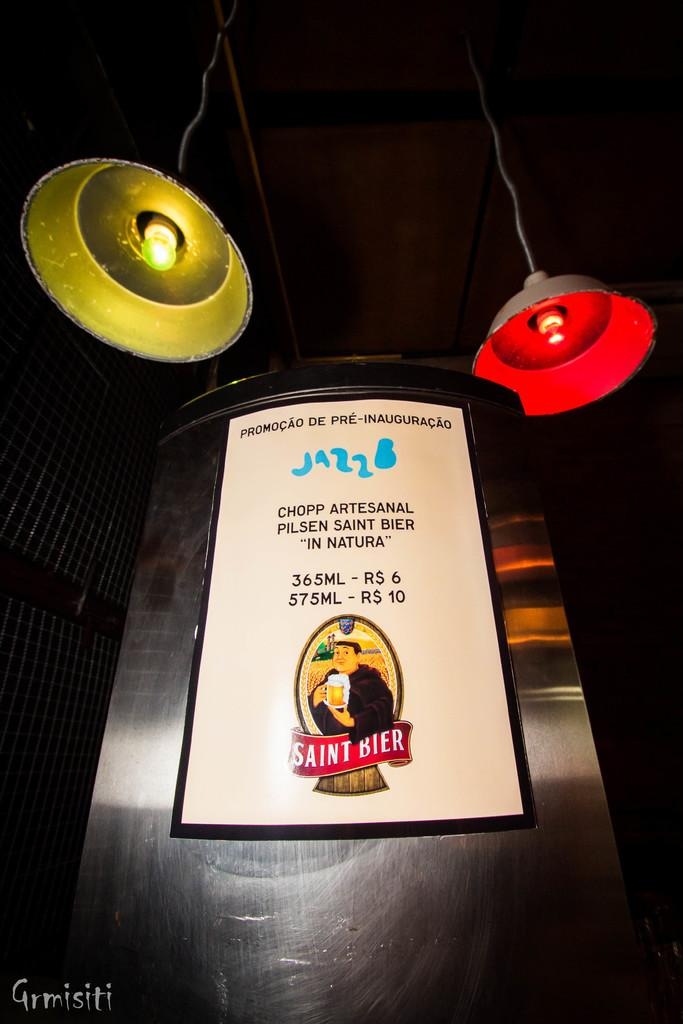<image>
Give a short and clear explanation of the subsequent image. A menu from Saint Bier has a picture of a man holding a beer on it. 